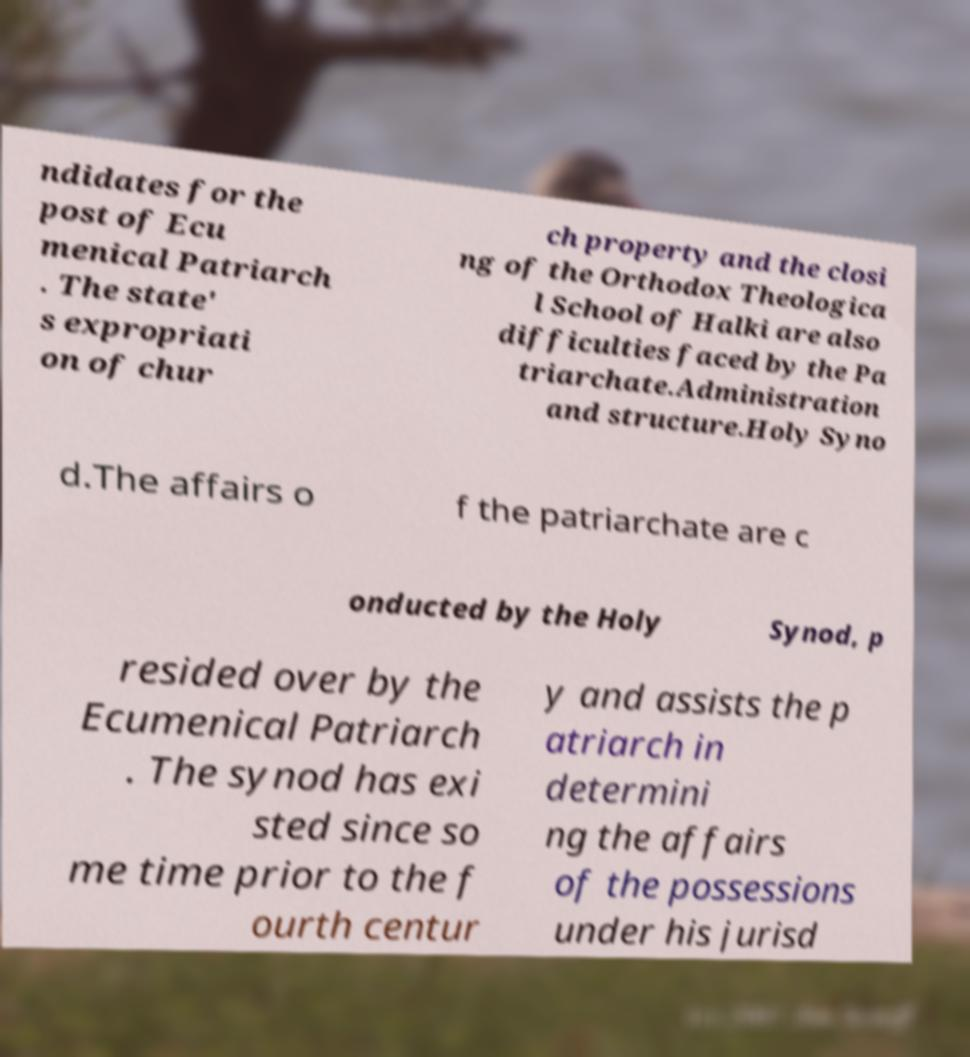Please identify and transcribe the text found in this image. ndidates for the post of Ecu menical Patriarch . The state' s expropriati on of chur ch property and the closi ng of the Orthodox Theologica l School of Halki are also difficulties faced by the Pa triarchate.Administration and structure.Holy Syno d.The affairs o f the patriarchate are c onducted by the Holy Synod, p resided over by the Ecumenical Patriarch . The synod has exi sted since so me time prior to the f ourth centur y and assists the p atriarch in determini ng the affairs of the possessions under his jurisd 